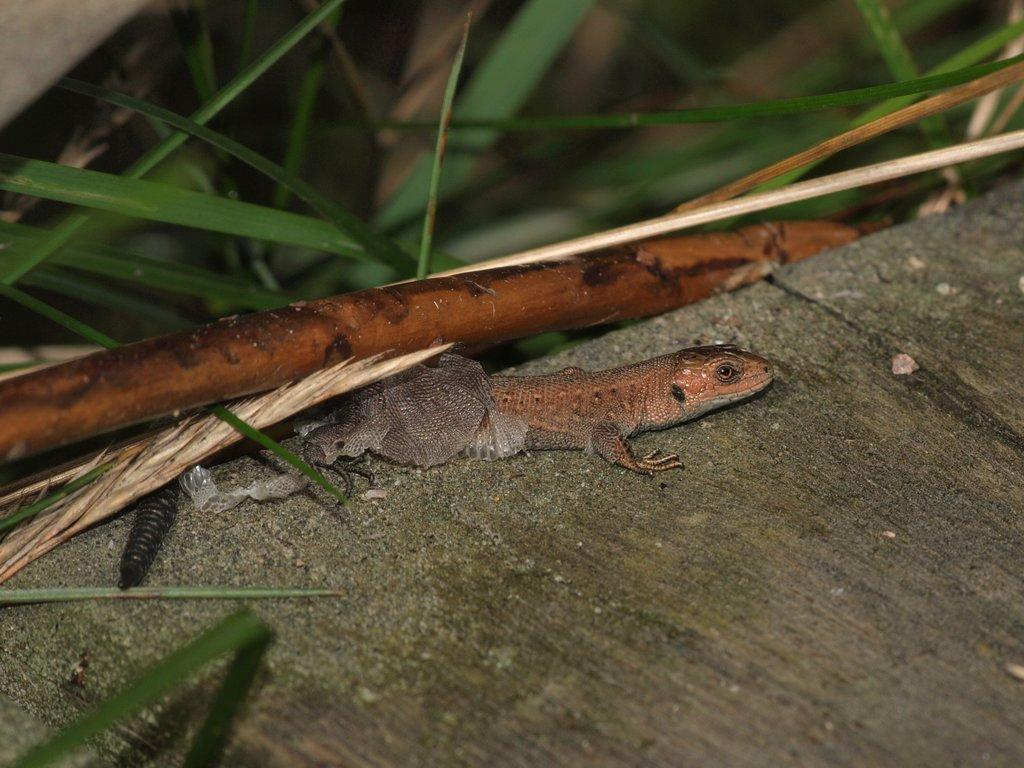What type of animal is on the ground in the image? There is a reptile on the ground in the image. What else can be seen in the image besides the reptile? Leaves of a plant are visible at the top of the image. What arithmetic problem is the reptile trying to solve in the image? There is no arithmetic problem present in the image; it features a reptile and leaves of a plant. 